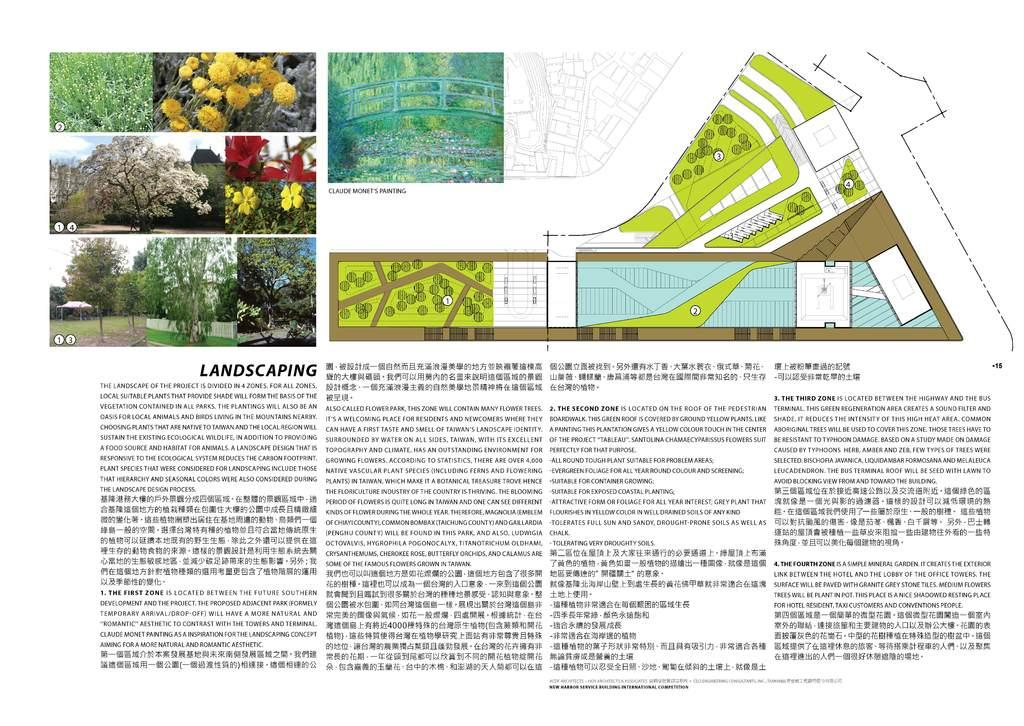What can be seen in the picture? There are images in the picture. What accompanies the images in the picture? There is text written below the images. What type of necklace is being worn by the person in the image? There is no person or necklace present in the image; it only contains images and text. 